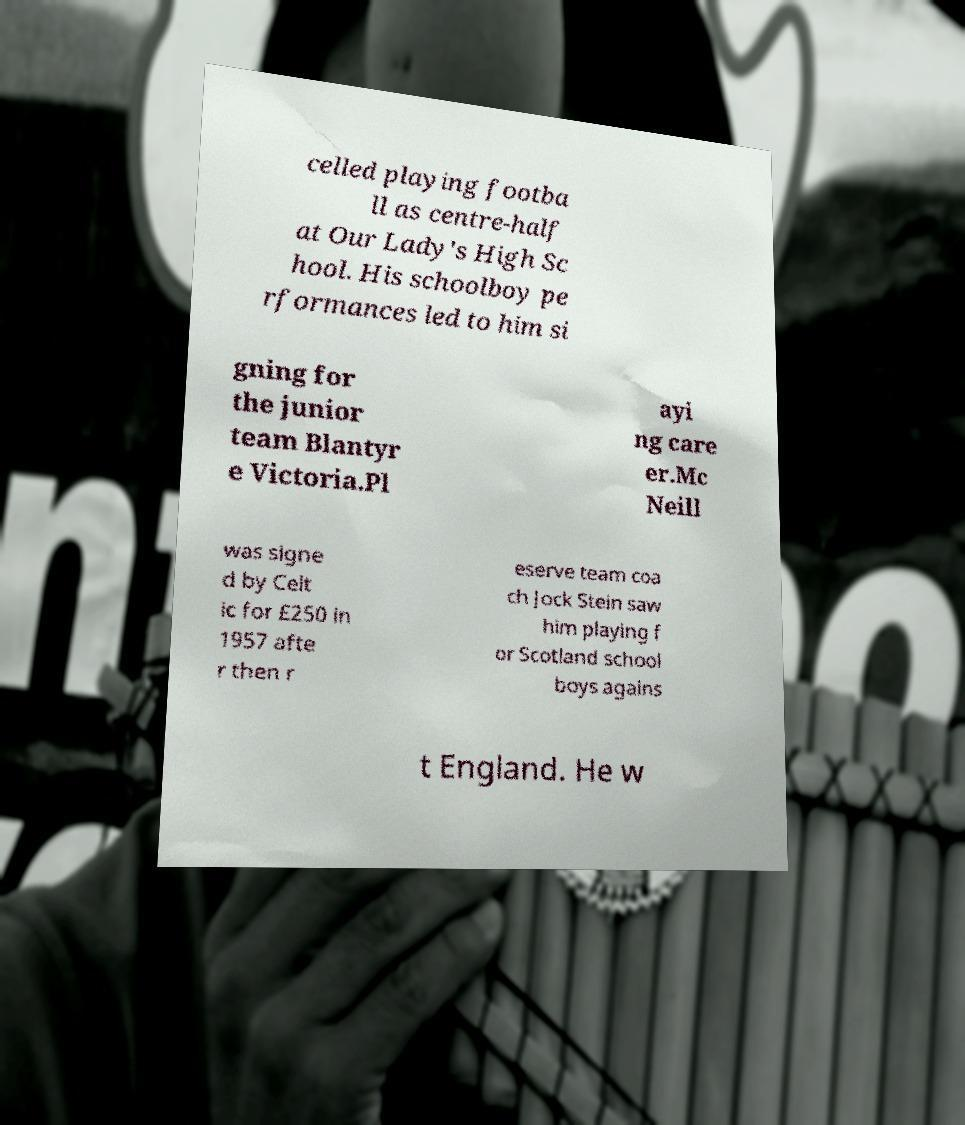Can you accurately transcribe the text from the provided image for me? celled playing footba ll as centre-half at Our Lady's High Sc hool. His schoolboy pe rformances led to him si gning for the junior team Blantyr e Victoria.Pl ayi ng care er.Mc Neill was signe d by Celt ic for £250 in 1957 afte r then r eserve team coa ch Jock Stein saw him playing f or Scotland school boys agains t England. He w 